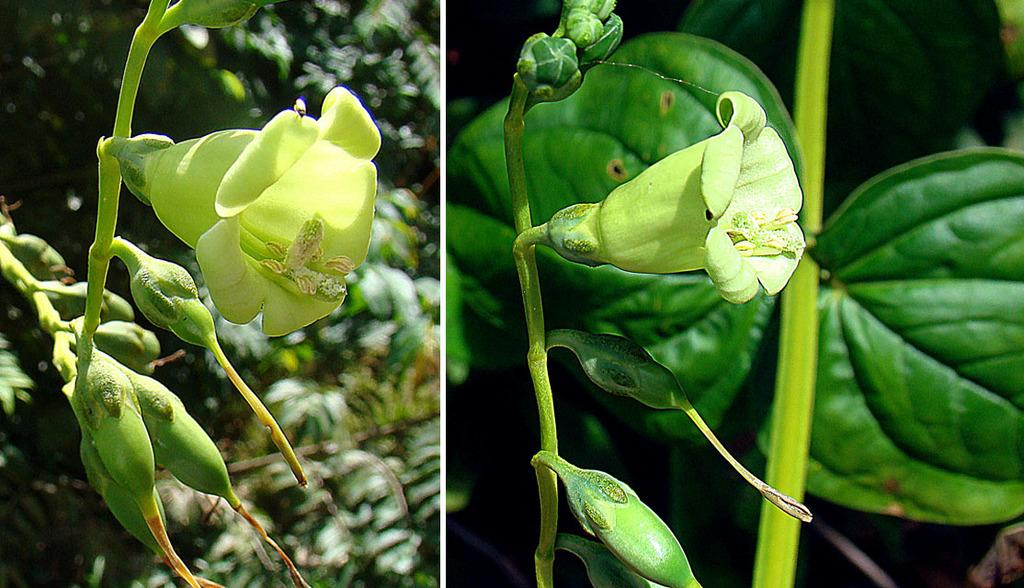What type of institution is depicted in the image? The image is of a college. What can be seen in the center of the image? There are flowers, leaves, plants, and trees in the center of the image. What type of nerve can be seen in the image? There is no nerve present in the image; it features a college with flowers, leaves, plants, and trees in the center. What time of day is it in the image? The time of day cannot be determined from the image alone. 